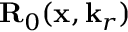Convert formula to latex. <formula><loc_0><loc_0><loc_500><loc_500>{ R } _ { 0 } ( x , k _ { r } )</formula> 